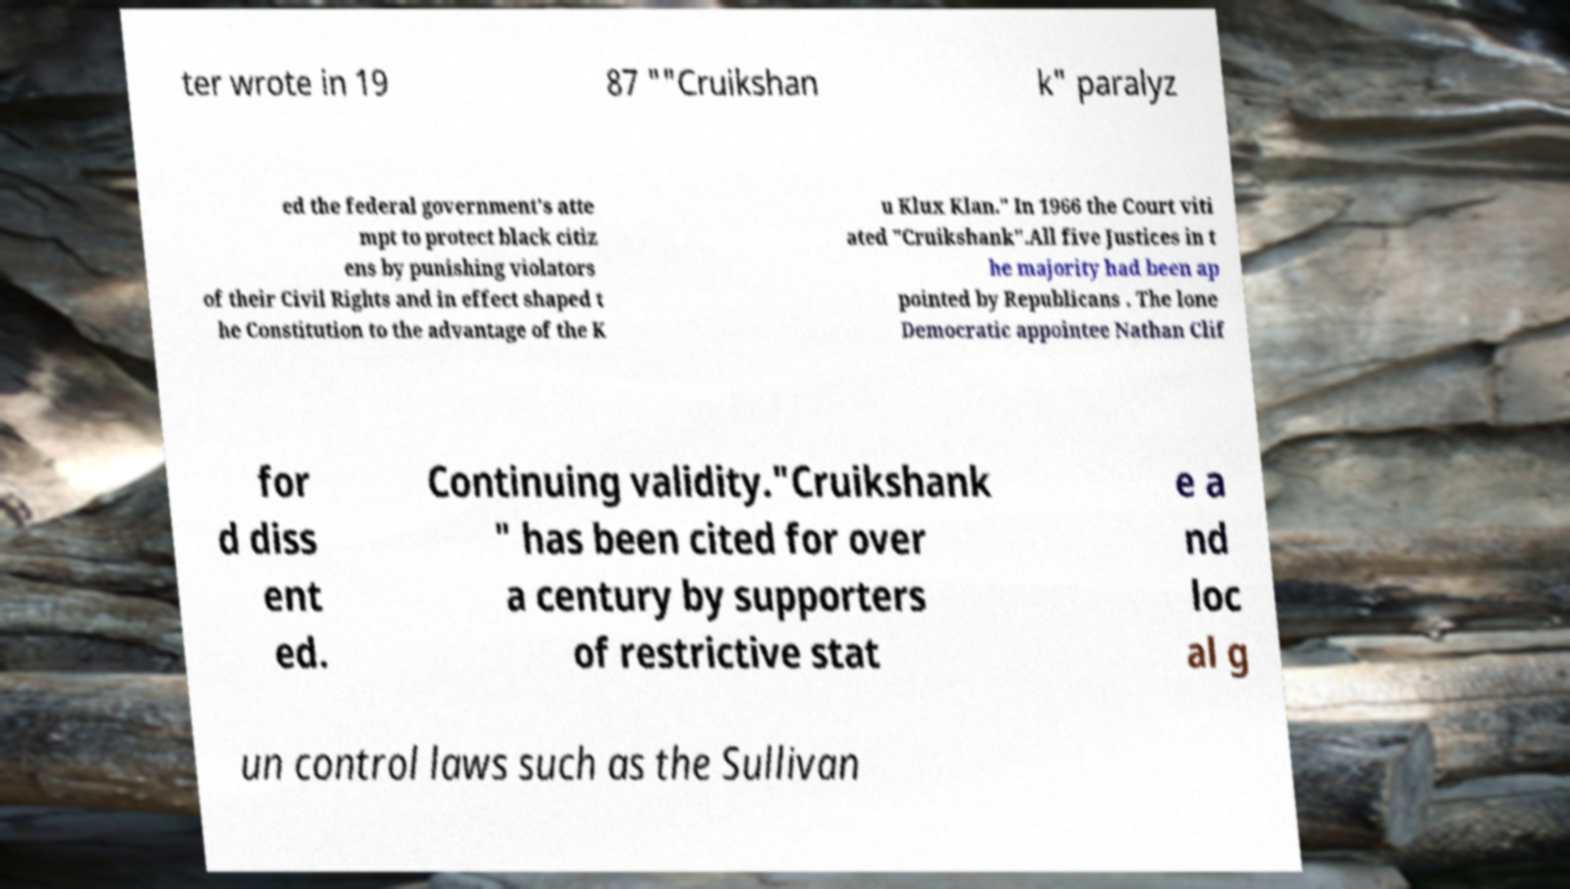Can you read and provide the text displayed in the image?This photo seems to have some interesting text. Can you extract and type it out for me? ter wrote in 19 87 ""Cruikshan k" paralyz ed the federal government's atte mpt to protect black citiz ens by punishing violators of their Civil Rights and in effect shaped t he Constitution to the advantage of the K u Klux Klan." In 1966 the Court viti ated "Cruikshank".All five Justices in t he majority had been ap pointed by Republicans . The lone Democratic appointee Nathan Clif for d diss ent ed. Continuing validity."Cruikshank " has been cited for over a century by supporters of restrictive stat e a nd loc al g un control laws such as the Sullivan 